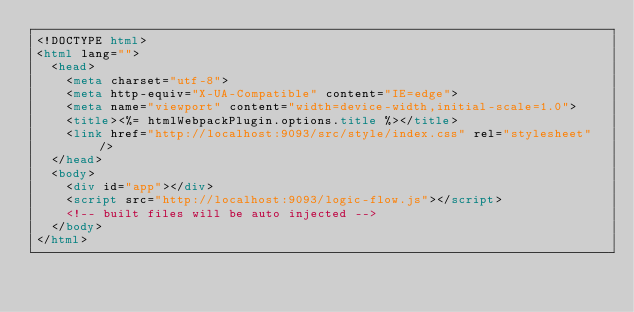Convert code to text. <code><loc_0><loc_0><loc_500><loc_500><_HTML_><!DOCTYPE html>
<html lang="">
  <head>
    <meta charset="utf-8">
    <meta http-equiv="X-UA-Compatible" content="IE=edge">
    <meta name="viewport" content="width=device-width,initial-scale=1.0">
    <title><%= htmlWebpackPlugin.options.title %></title>
    <link href="http://localhost:9093/src/style/index.css" rel="stylesheet" />
  </head>
  <body>
    <div id="app"></div>
    <script src="http://localhost:9093/logic-flow.js"></script>
    <!-- built files will be auto injected -->
  </body>
</html>
</code> 